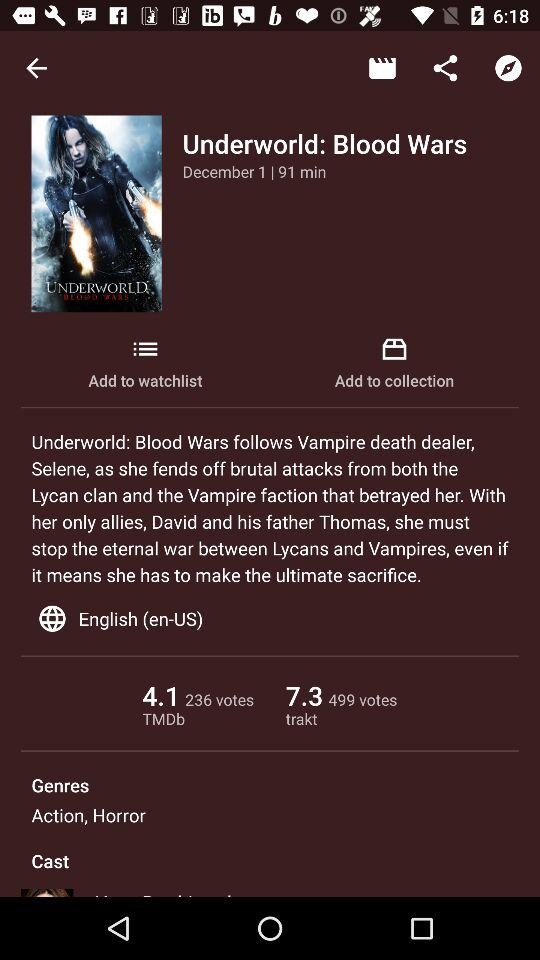How many more votes does the TMDb rating have than the IMDb rating?
Answer the question using a single word or phrase. 263 